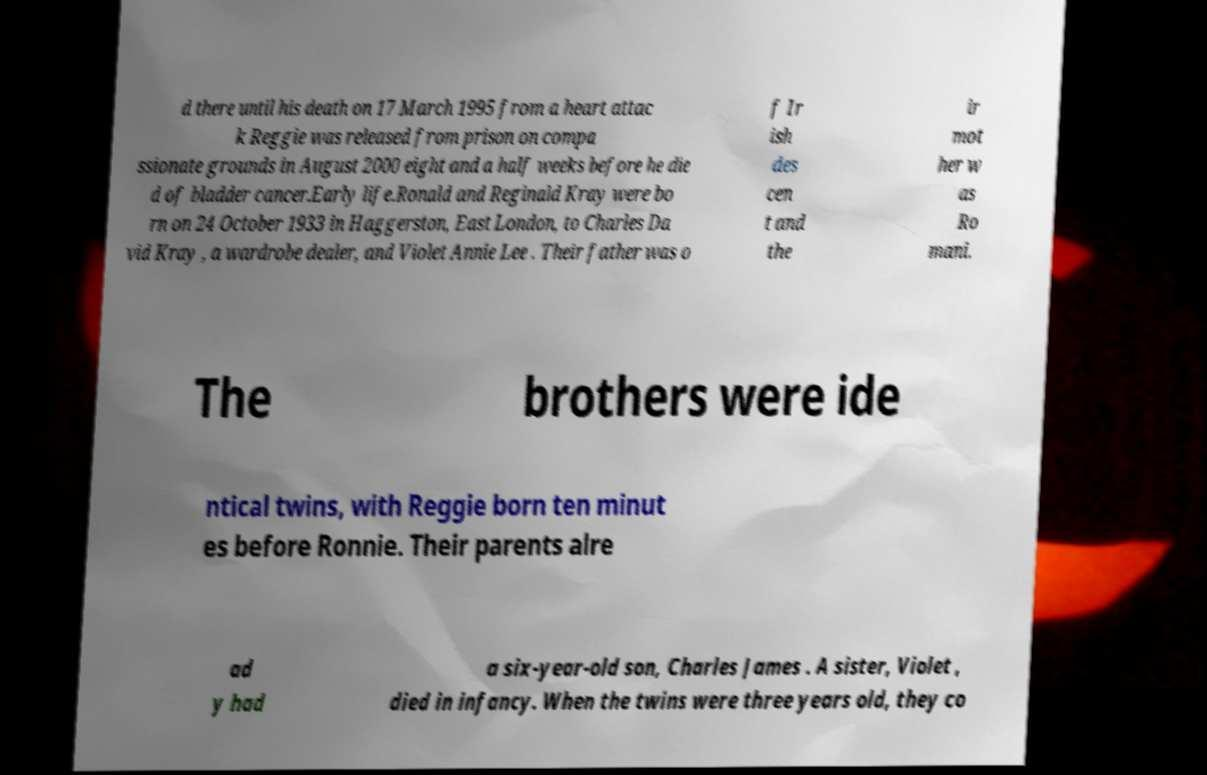For documentation purposes, I need the text within this image transcribed. Could you provide that? d there until his death on 17 March 1995 from a heart attac k Reggie was released from prison on compa ssionate grounds in August 2000 eight and a half weeks before he die d of bladder cancer.Early life.Ronald and Reginald Kray were bo rn on 24 October 1933 in Haggerston, East London, to Charles Da vid Kray , a wardrobe dealer, and Violet Annie Lee . Their father was o f Ir ish des cen t and the ir mot her w as Ro mani. The brothers were ide ntical twins, with Reggie born ten minut es before Ronnie. Their parents alre ad y had a six-year-old son, Charles James . A sister, Violet , died in infancy. When the twins were three years old, they co 